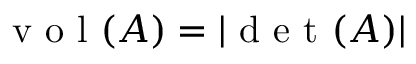Convert formula to latex. <formula><loc_0><loc_0><loc_500><loc_500>v o l ( A ) = | d e t ( A ) |</formula> 